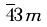Convert formula to latex. <formula><loc_0><loc_0><loc_500><loc_500>\overline { 4 } 3 m</formula> 